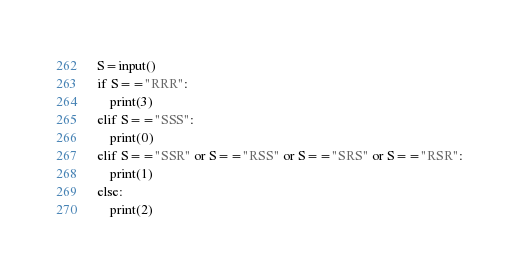Convert code to text. <code><loc_0><loc_0><loc_500><loc_500><_Python_>S=input()
if S=="RRR":
    print(3)
elif S=="SSS":
    print(0)
elif S=="SSR" or S=="RSS" or S=="SRS" or S=="RSR":
    print(1)
else:
    print(2)</code> 